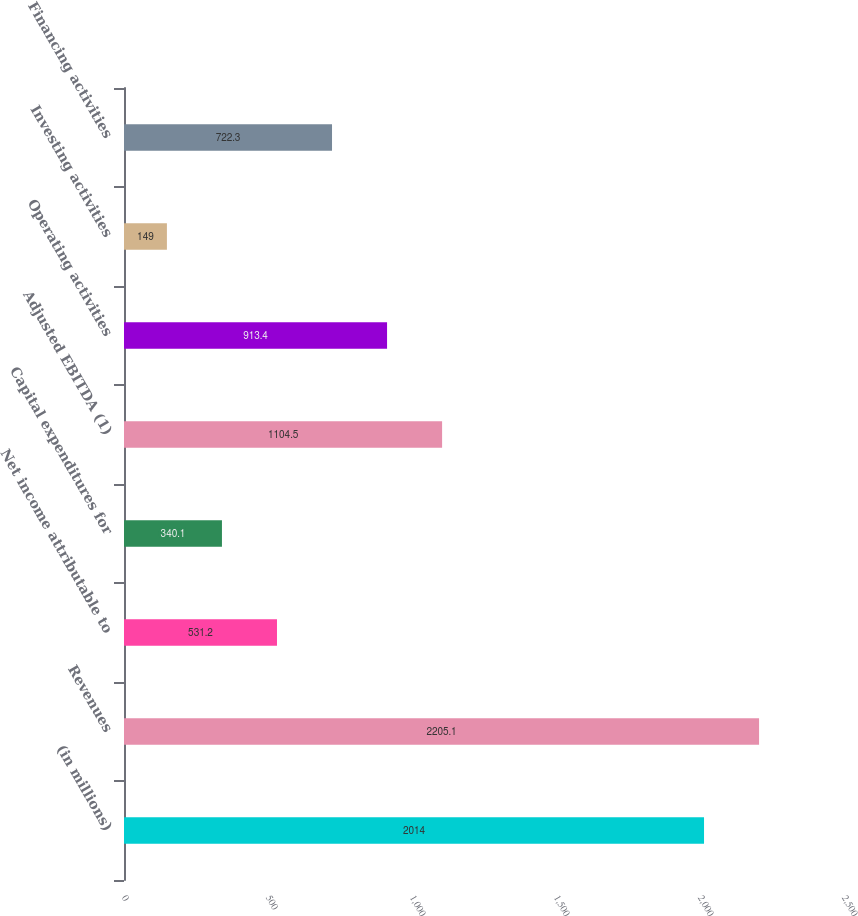Convert chart to OTSL. <chart><loc_0><loc_0><loc_500><loc_500><bar_chart><fcel>(in millions)<fcel>Revenues<fcel>Net income attributable to<fcel>Capital expenditures for<fcel>Adjusted EBITDA (1)<fcel>Operating activities<fcel>Investing activities<fcel>Financing activities<nl><fcel>2014<fcel>2205.1<fcel>531.2<fcel>340.1<fcel>1104.5<fcel>913.4<fcel>149<fcel>722.3<nl></chart> 